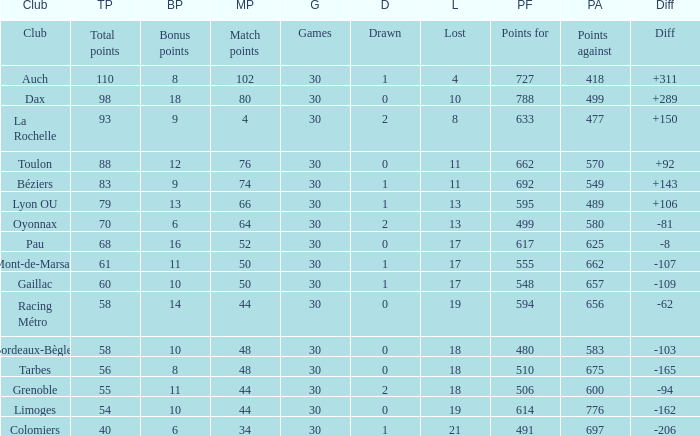Could you parse the entire table? {'header': ['Club', 'TP', 'BP', 'MP', 'G', 'D', 'L', 'PF', 'PA', 'Diff'], 'rows': [['Club', 'Total points', 'Bonus points', 'Match points', 'Games', 'Drawn', 'Lost', 'Points for', 'Points against', 'Diff'], ['Auch', '110', '8', '102', '30', '1', '4', '727', '418', '+311'], ['Dax', '98', '18', '80', '30', '0', '10', '788', '499', '+289'], ['La Rochelle', '93', '9', '4', '30', '2', '8', '633', '477', '+150'], ['Toulon', '88', '12', '76', '30', '0', '11', '662', '570', '+92'], ['Béziers', '83', '9', '74', '30', '1', '11', '692', '549', '+143'], ['Lyon OU', '79', '13', '66', '30', '1', '13', '595', '489', '+106'], ['Oyonnax', '70', '6', '64', '30', '2', '13', '499', '580', '-81'], ['Pau', '68', '16', '52', '30', '0', '17', '617', '625', '-8'], ['Mont-de-Marsan', '61', '11', '50', '30', '1', '17', '555', '662', '-107'], ['Gaillac', '60', '10', '50', '30', '1', '17', '548', '657', '-109'], ['Racing Métro', '58', '14', '44', '30', '0', '19', '594', '656', '-62'], ['Bordeaux-Bègles', '58', '10', '48', '30', '0', '18', '480', '583', '-103'], ['Tarbes', '56', '8', '48', '30', '0', '18', '510', '675', '-165'], ['Grenoble', '55', '11', '44', '30', '2', '18', '506', '600', '-94'], ['Limoges', '54', '10', '44', '30', '0', '19', '614', '776', '-162'], ['Colomiers', '40', '6', '34', '30', '1', '21', '491', '697', '-206']]} What is the number of games for a club that has 34 match points? 30.0. 